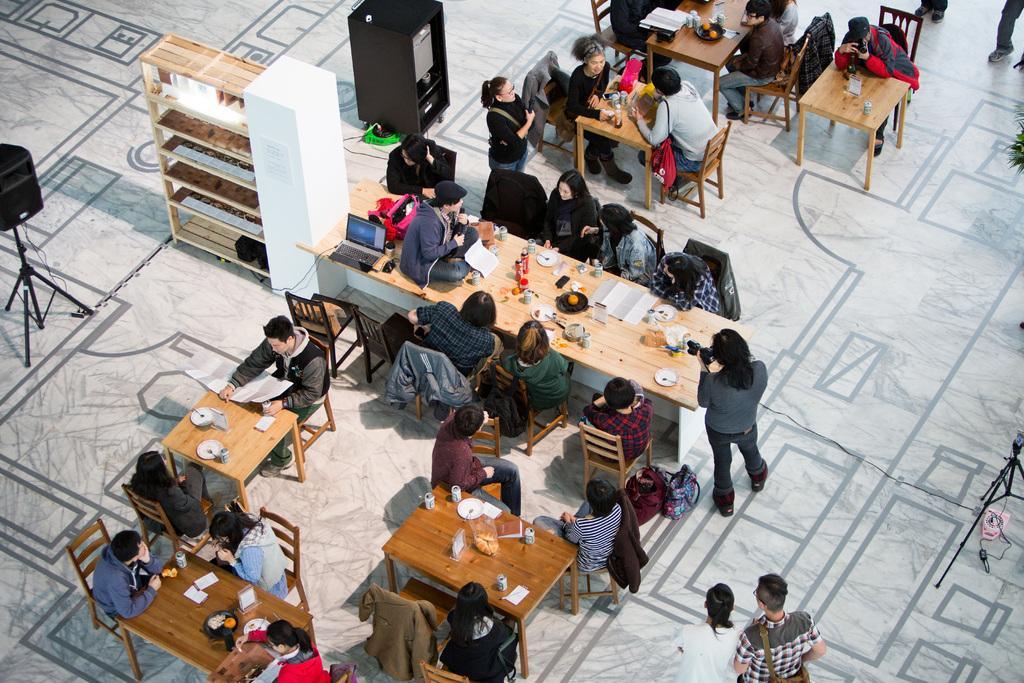Can you describe this image briefly? In this picture we can see persons sitting on chairs in front of a table and on the table we can see plates, spoons, tins, papers, plate of food. We can see few persons standing and walking on the floor. This is a machine. Here we can see stand with a speaker. This is a rack. We can see one man sitting on a table , beside to him there is a backpack and laptop. 